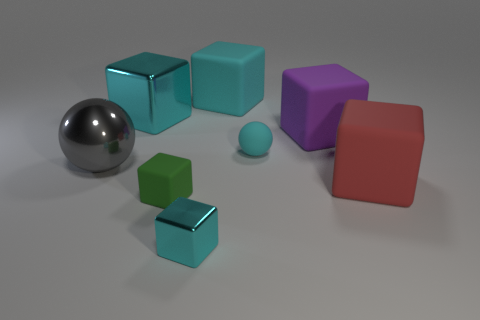How many cyan blocks must be subtracted to get 1 cyan blocks? 2 Subtract all big blocks. How many blocks are left? 2 Subtract all spheres. How many objects are left? 6 Add 2 small red rubber balls. How many objects exist? 10 Subtract all purple balls. How many cyan cubes are left? 3 Subtract 2 balls. How many balls are left? 0 Subtract all large purple matte cylinders. Subtract all cyan spheres. How many objects are left? 7 Add 3 large red rubber objects. How many large red rubber objects are left? 4 Add 5 small cyan rubber things. How many small cyan rubber things exist? 6 Subtract all red blocks. How many blocks are left? 5 